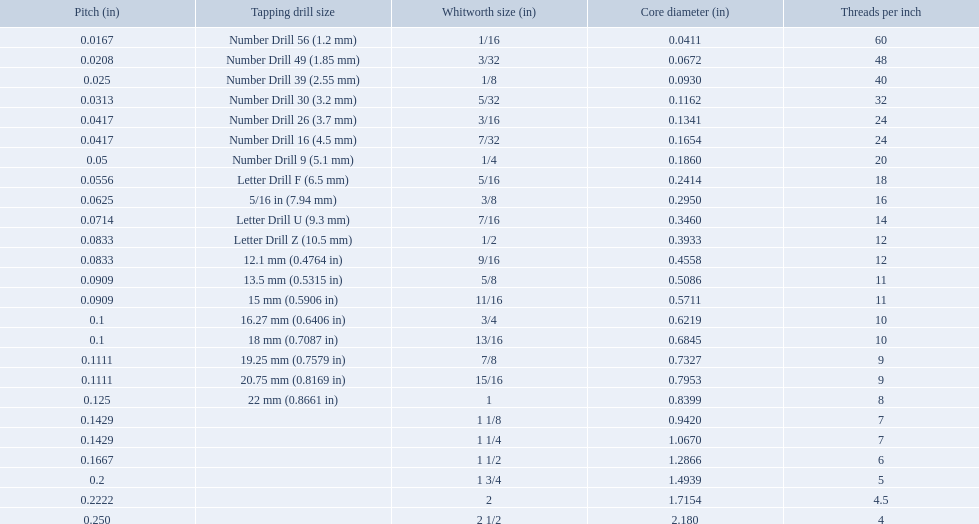What are all the whitworth sizes? 1/16, 3/32, 1/8, 5/32, 3/16, 7/32, 1/4, 5/16, 3/8, 7/16, 1/2, 9/16, 5/8, 11/16, 3/4, 13/16, 7/8, 15/16, 1, 1 1/8, 1 1/4, 1 1/2, 1 3/4, 2, 2 1/2. Parse the full table. {'header': ['Pitch (in)', 'Tapping drill size', 'Whitworth size (in)', 'Core diameter (in)', 'Threads per\xa0inch'], 'rows': [['0.0167', 'Number Drill 56 (1.2\xa0mm)', '1/16', '0.0411', '60'], ['0.0208', 'Number Drill 49 (1.85\xa0mm)', '3/32', '0.0672', '48'], ['0.025', 'Number Drill 39 (2.55\xa0mm)', '1/8', '0.0930', '40'], ['0.0313', 'Number Drill 30 (3.2\xa0mm)', '5/32', '0.1162', '32'], ['0.0417', 'Number Drill 26 (3.7\xa0mm)', '3/16', '0.1341', '24'], ['0.0417', 'Number Drill 16 (4.5\xa0mm)', '7/32', '0.1654', '24'], ['0.05', 'Number Drill 9 (5.1\xa0mm)', '1/4', '0.1860', '20'], ['0.0556', 'Letter Drill F (6.5\xa0mm)', '5/16', '0.2414', '18'], ['0.0625', '5/16\xa0in (7.94\xa0mm)', '3/8', '0.2950', '16'], ['0.0714', 'Letter Drill U (9.3\xa0mm)', '7/16', '0.3460', '14'], ['0.0833', 'Letter Drill Z (10.5\xa0mm)', '1/2', '0.3933', '12'], ['0.0833', '12.1\xa0mm (0.4764\xa0in)', '9/16', '0.4558', '12'], ['0.0909', '13.5\xa0mm (0.5315\xa0in)', '5/8', '0.5086', '11'], ['0.0909', '15\xa0mm (0.5906\xa0in)', '11/16', '0.5711', '11'], ['0.1', '16.27\xa0mm (0.6406\xa0in)', '3/4', '0.6219', '10'], ['0.1', '18\xa0mm (0.7087\xa0in)', '13/16', '0.6845', '10'], ['0.1111', '19.25\xa0mm (0.7579\xa0in)', '7/8', '0.7327', '9'], ['0.1111', '20.75\xa0mm (0.8169\xa0in)', '15/16', '0.7953', '9'], ['0.125', '22\xa0mm (0.8661\xa0in)', '1', '0.8399', '8'], ['0.1429', '', '1 1/8', '0.9420', '7'], ['0.1429', '', '1 1/4', '1.0670', '7'], ['0.1667', '', '1 1/2', '1.2866', '6'], ['0.2', '', '1 3/4', '1.4939', '5'], ['0.2222', '', '2', '1.7154', '4.5'], ['0.250', '', '2 1/2', '2.180', '4']]} What are the threads per inch of these sizes? 60, 48, 40, 32, 24, 24, 20, 18, 16, 14, 12, 12, 11, 11, 10, 10, 9, 9, 8, 7, 7, 6, 5, 4.5, 4. Of these, which are 5? 5. What whitworth size has this threads per inch? 1 3/4. What are the whitworth sizes? 1/16, 3/32, 1/8, 5/32, 3/16, 7/32, 1/4, 5/16, 3/8, 7/16, 1/2, 9/16, 5/8, 11/16, 3/4, 13/16, 7/8, 15/16, 1, 1 1/8, 1 1/4, 1 1/2, 1 3/4, 2, 2 1/2. And their threads per inch? 60, 48, 40, 32, 24, 24, 20, 18, 16, 14, 12, 12, 11, 11, 10, 10, 9, 9, 8, 7, 7, 6, 5, 4.5, 4. Now, which whitworth size has a thread-per-inch size of 5?? 1 3/4. What was the core diameter of a number drill 26 0.1341. What is this measurement in whitworth size? 3/16. 